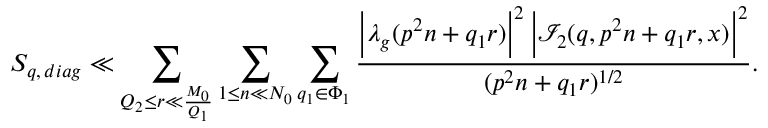<formula> <loc_0><loc_0><loc_500><loc_500>S _ { q , \, d i a g } \ll \sum _ { Q _ { 2 } \leq r \ll \frac { M _ { 0 } } { Q _ { 1 } } } \sum _ { 1 \leq n \ll N _ { 0 } } \sum _ { q _ { 1 } \in \Phi _ { 1 } } \frac { \left | \lambda _ { g } ( p ^ { 2 } n + q _ { 1 } r ) \right | ^ { 2 } \, \left | \mathcal { I } _ { 2 } ( q , p ^ { 2 } n + q _ { 1 } r , x ) \right | ^ { 2 } } { ( p ^ { 2 } n + q _ { 1 } r ) ^ { 1 / 2 } } .</formula> 